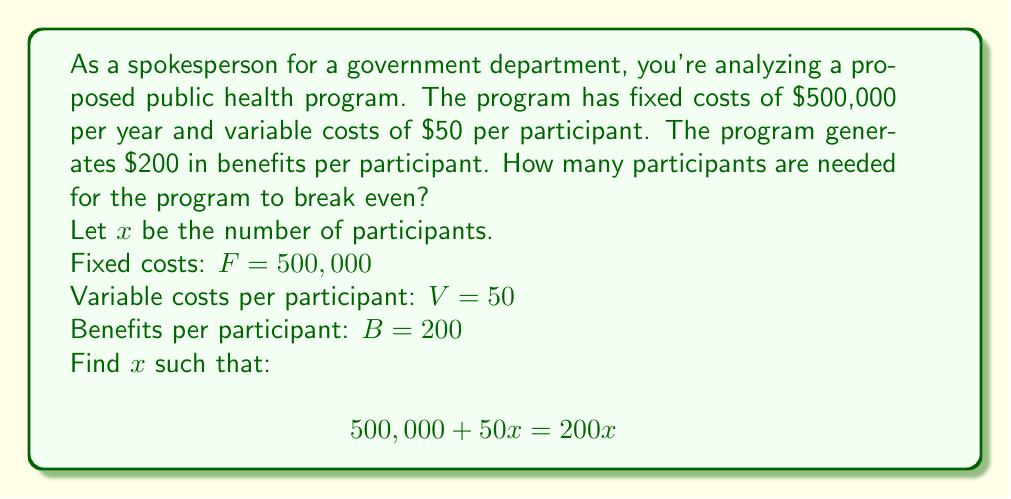Give your solution to this math problem. To solve for the break-even point, we need to find the number of participants where the total costs equal the total benefits.

1) Set up the equation:
   Total Costs = Total Benefits
   $$ 500,000 + 50x = 200x $$

2) Subtract 50x from both sides:
   $$ 500,000 = 150x $$

3) Divide both sides by 150:
   $$ \frac{500,000}{150} = x $$

4) Simplify:
   $$ 3,333.33 = x $$

5) Since we can't have a fractional participant, we round up to the nearest whole number:
   $$ x = 3,334 $$

Therefore, the program needs 3,334 participants to break even.

To verify:
- Total Costs: $500,000 + (50 * 3,334) = 666,700$
- Total Benefits: $200 * 3,334 = 666,800$

The benefits slightly exceed the costs at this point, confirming the break-even point.
Answer: The program needs 3,334 participants to break even. 